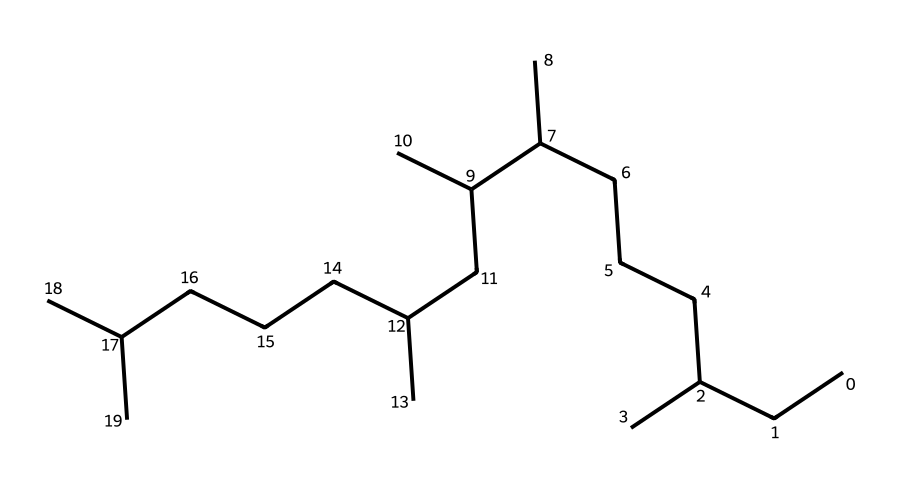What is the primary functional group present in this chemical? The structure provided is a type of hydrocarbons known as alkanes since it only contains carbon and hydrogen atoms connected by single bonds. Alkanes do not contain functional groups like alcohols or amines, which have distinct functional groups.
Answer: alkane How many carbon atoms are present in this chemical? To determine the number of carbon atoms, I will count each carbon (C) symbol in the SMILES notation. Each "C" corresponds to a carbon atom, and by counting all visible carbons, we find a total of 30 carbon atoms.
Answer: 30 Is this chemical saturated or unsaturated? The structure includes only single bonds between the carbon atoms, which indicates it is saturated. Saturated hydrocarbon chains have the maximum number of hydrogen atoms per carbon, as seen in the given structure.
Answer: saturated What is the molar mass of this chemical? First, the formula for alkanes is CnH2n+2. With 30 carbon atoms (n=30), we calculate the number of hydrogen atoms: H2(30)+2 = 62. Then I calculate the molar mass: (30*12.01) + (62*1.008) = 366.18 g/mol.
Answer: 366.18 What properties make this chemical suitable for use in computer cooling systems? The chemical's high thermal stability and low volatility, characteristic of polyalphaolefins, provide excellent lubricating properties at various temperatures. These factors contribute to efficient heat transfer and reduced friction in computer components.
Answer: thermal stability How many hydrogen atoms are bonded to the carbon atoms in this structure? Each carbon in an alkane typically bonds with enough hydrogen to make four total bonds. As determined previously, there are 30 carbon atoms and calculating using CnH2n+2, the number of hydrogen atoms is 62.
Answer: 62 What is the common application of this polyalphaolefin? Polyalphaolefins are commonly used as synthetic lubricants due to their desirable properties like low volatility and excellent stability, making them suitable for cooling systems.
Answer: synthetic lubricants 